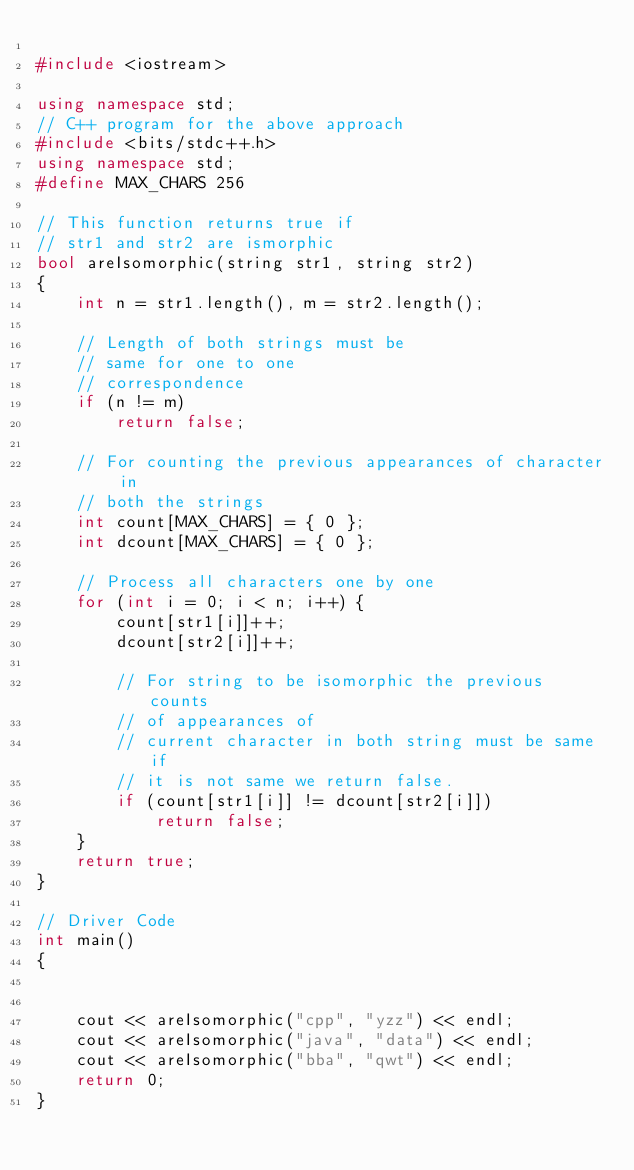Convert code to text. <code><loc_0><loc_0><loc_500><loc_500><_C++_>
#include <iostream>

using namespace std;
// C++ program for the above approach
#include <bits/stdc++.h>
using namespace std;
#define MAX_CHARS 256

// This function returns true if
// str1 and str2 are ismorphic
bool areIsomorphic(string str1, string str2)
{
	int n = str1.length(), m = str2.length();

	// Length of both strings must be
	// same for one to one
	// correspondence
	if (n != m)
		return false;

	// For counting the previous appearances of character in
	// both the strings
	int count[MAX_CHARS] = { 0 };
	int dcount[MAX_CHARS] = { 0 };

	// Process all characters one by one
	for (int i = 0; i < n; i++) {
		count[str1[i]]++;
		dcount[str2[i]]++;

		// For string to be isomorphic the previous counts
		// of appearances of
		// current character in both string must be same if
		// it is not same we return false.
		if (count[str1[i]] != dcount[str2[i]])
			return false;
	}
	return true;
}

// Driver Code
int main()
{
	

	cout << areIsomorphic("cpp", "yzz") << endl;
	cout << areIsomorphic("java", "data") << endl;
	cout << areIsomorphic("bba", "qwt") << endl;
	return 0;
}

</code> 